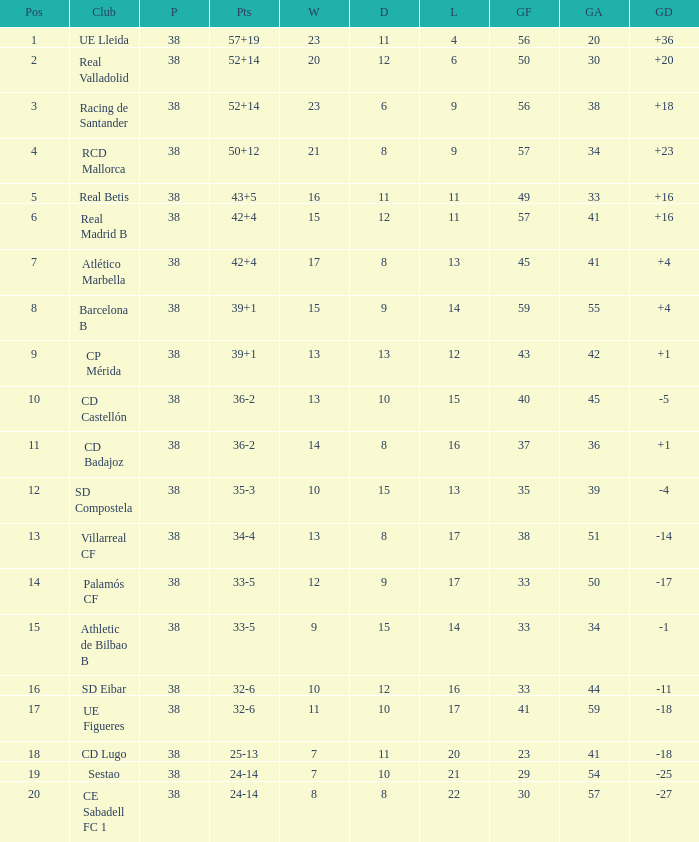What is the highest number of wins with a goal difference less than 4 at the Villarreal CF and more than 38 played? None. 